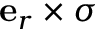Convert formula to latex. <formula><loc_0><loc_0><loc_500><loc_500>e _ { r } \times \boldsymbol \sigma</formula> 